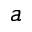<formula> <loc_0><loc_0><loc_500><loc_500>a</formula> 